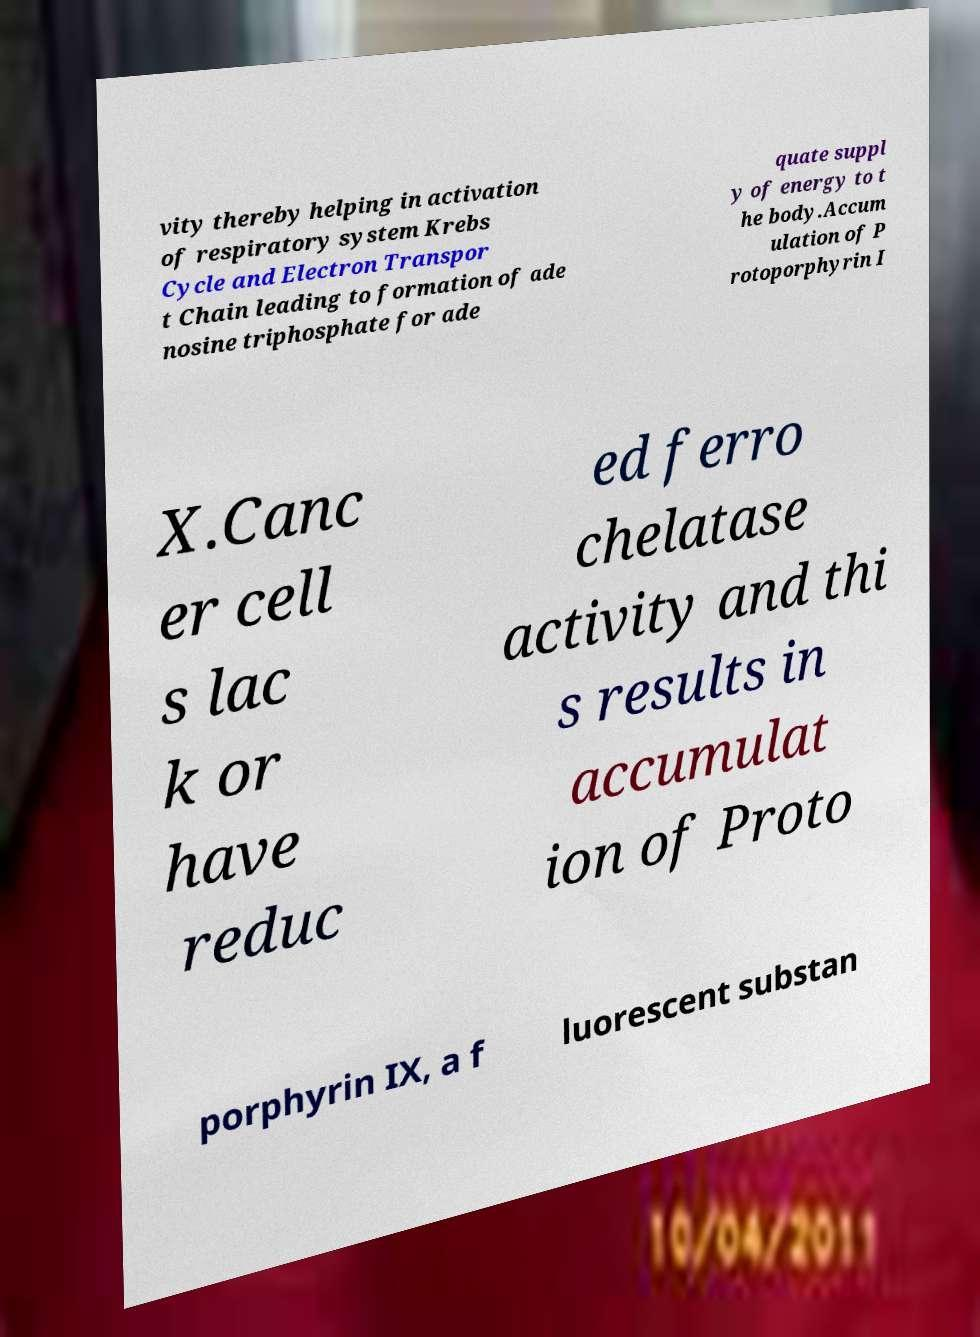Could you assist in decoding the text presented in this image and type it out clearly? vity thereby helping in activation of respiratory system Krebs Cycle and Electron Transpor t Chain leading to formation of ade nosine triphosphate for ade quate suppl y of energy to t he body.Accum ulation of P rotoporphyrin I X.Canc er cell s lac k or have reduc ed ferro chelatase activity and thi s results in accumulat ion of Proto porphyrin IX, a f luorescent substan 